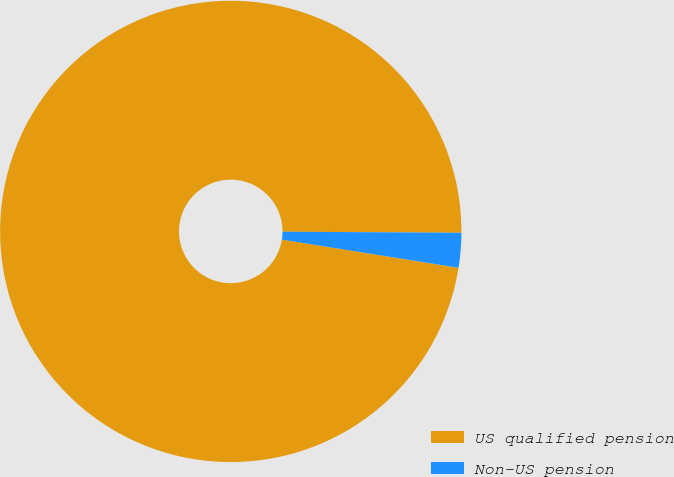Convert chart to OTSL. <chart><loc_0><loc_0><loc_500><loc_500><pie_chart><fcel>US qualified pension<fcel>Non-US pension<nl><fcel>97.57%<fcel>2.43%<nl></chart> 